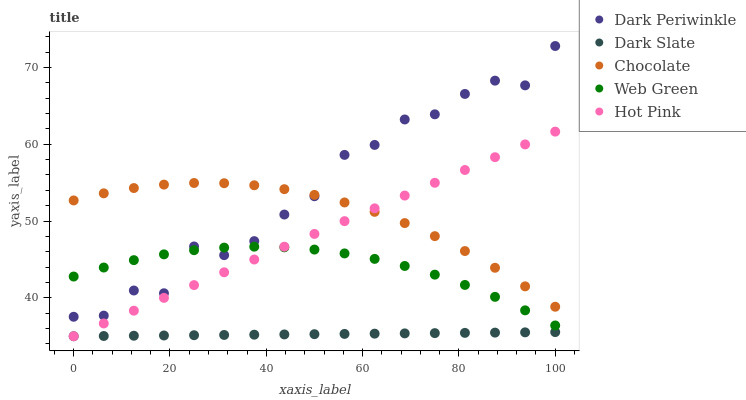Does Dark Slate have the minimum area under the curve?
Answer yes or no. Yes. Does Dark Periwinkle have the maximum area under the curve?
Answer yes or no. Yes. Does Hot Pink have the minimum area under the curve?
Answer yes or no. No. Does Hot Pink have the maximum area under the curve?
Answer yes or no. No. Is Dark Slate the smoothest?
Answer yes or no. Yes. Is Dark Periwinkle the roughest?
Answer yes or no. Yes. Is Hot Pink the smoothest?
Answer yes or no. No. Is Hot Pink the roughest?
Answer yes or no. No. Does Dark Slate have the lowest value?
Answer yes or no. Yes. Does Dark Periwinkle have the lowest value?
Answer yes or no. No. Does Dark Periwinkle have the highest value?
Answer yes or no. Yes. Does Hot Pink have the highest value?
Answer yes or no. No. Is Dark Slate less than Dark Periwinkle?
Answer yes or no. Yes. Is Dark Periwinkle greater than Dark Slate?
Answer yes or no. Yes. Does Hot Pink intersect Chocolate?
Answer yes or no. Yes. Is Hot Pink less than Chocolate?
Answer yes or no. No. Is Hot Pink greater than Chocolate?
Answer yes or no. No. Does Dark Slate intersect Dark Periwinkle?
Answer yes or no. No. 